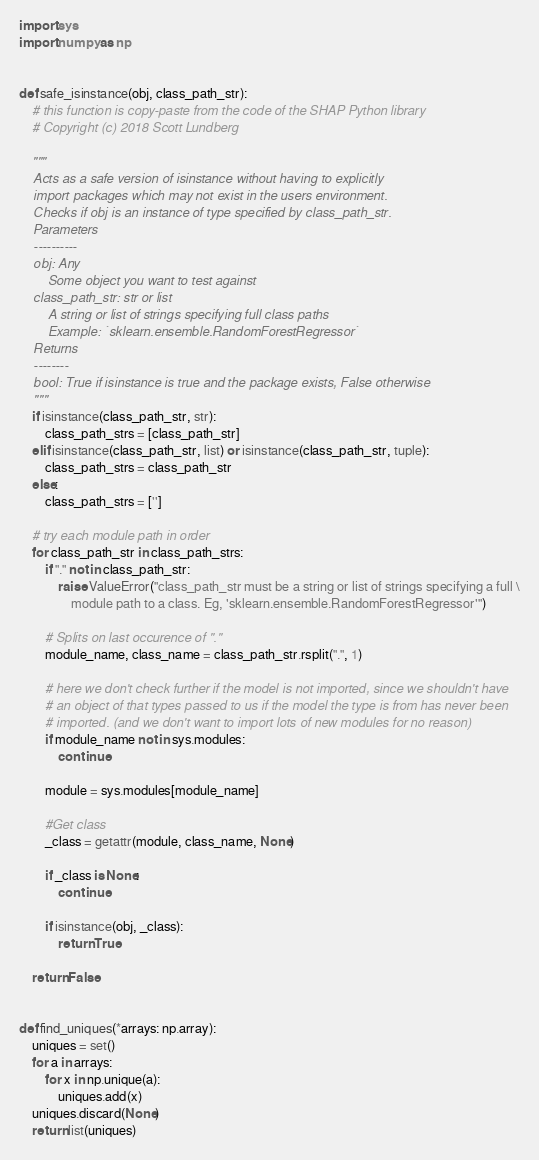Convert code to text. <code><loc_0><loc_0><loc_500><loc_500><_Python_>import sys
import numpy as np


def safe_isinstance(obj, class_path_str):
    # this function is copy-paste from the code of the SHAP Python library
    # Copyright (c) 2018 Scott Lundberg

    """
    Acts as a safe version of isinstance without having to explicitly
    import packages which may not exist in the users environment.
    Checks if obj is an instance of type specified by class_path_str.
    Parameters
    ----------
    obj: Any
        Some object you want to test against
    class_path_str: str or list
        A string or list of strings specifying full class paths
        Example: `sklearn.ensemble.RandomForestRegressor`
    Returns
    --------
    bool: True if isinstance is true and the package exists, False otherwise
    """
    if isinstance(class_path_str, str):
        class_path_strs = [class_path_str]
    elif isinstance(class_path_str, list) or isinstance(class_path_str, tuple):
        class_path_strs = class_path_str
    else:
        class_path_strs = ['']

    # try each module path in order
    for class_path_str in class_path_strs:
        if "." not in class_path_str:
            raise ValueError("class_path_str must be a string or list of strings specifying a full \
                module path to a class. Eg, 'sklearn.ensemble.RandomForestRegressor'")

        # Splits on last occurence of "."
        module_name, class_name = class_path_str.rsplit(".", 1)

        # here we don't check further if the model is not imported, since we shouldn't have
        # an object of that types passed to us if the model the type is from has never been
        # imported. (and we don't want to import lots of new modules for no reason)
        if module_name not in sys.modules:
            continue

        module = sys.modules[module_name]

        #Get class
        _class = getattr(module, class_name, None)

        if _class is None:
            continue

        if isinstance(obj, _class):
            return True

    return False


def find_uniques(*arrays: np.array):
    uniques = set()
    for a in arrays:
        for x in np.unique(a):
            uniques.add(x)
    uniques.discard(None)
    return list(uniques)
</code> 